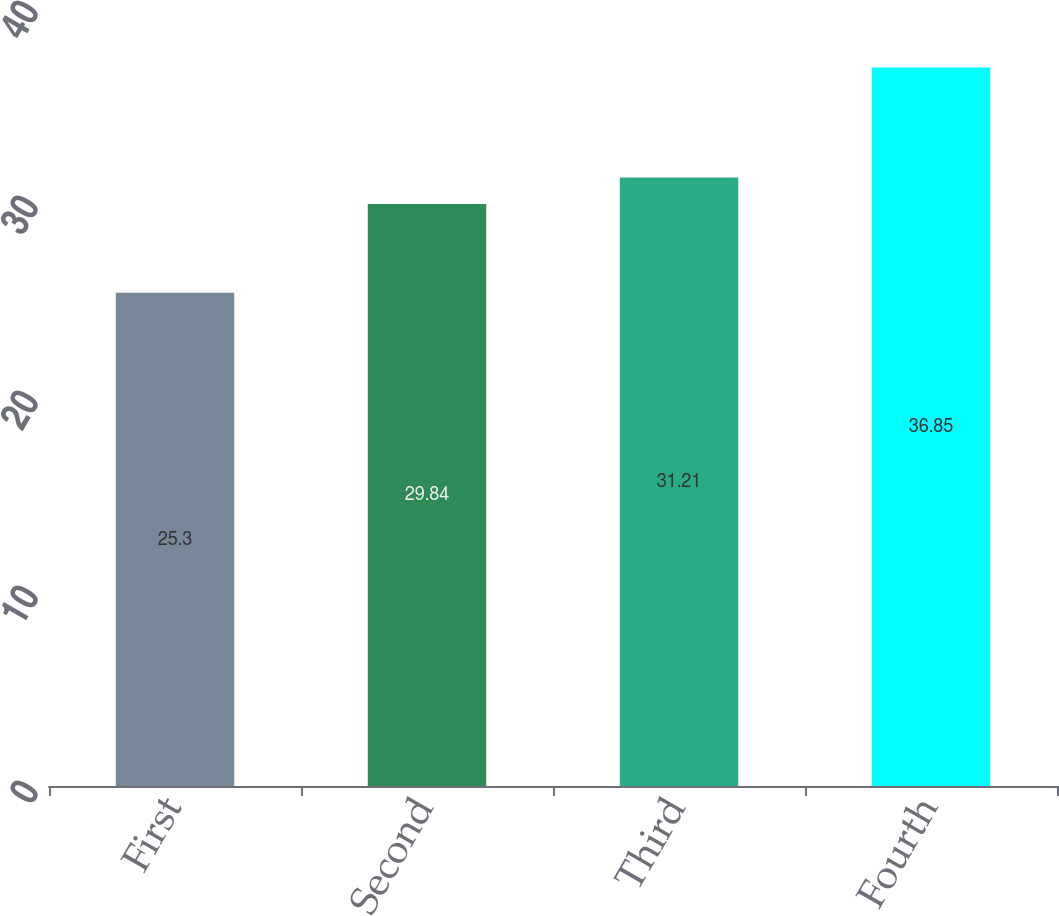Convert chart. <chart><loc_0><loc_0><loc_500><loc_500><bar_chart><fcel>First<fcel>Second<fcel>Third<fcel>Fourth<nl><fcel>25.3<fcel>29.84<fcel>31.21<fcel>36.85<nl></chart> 